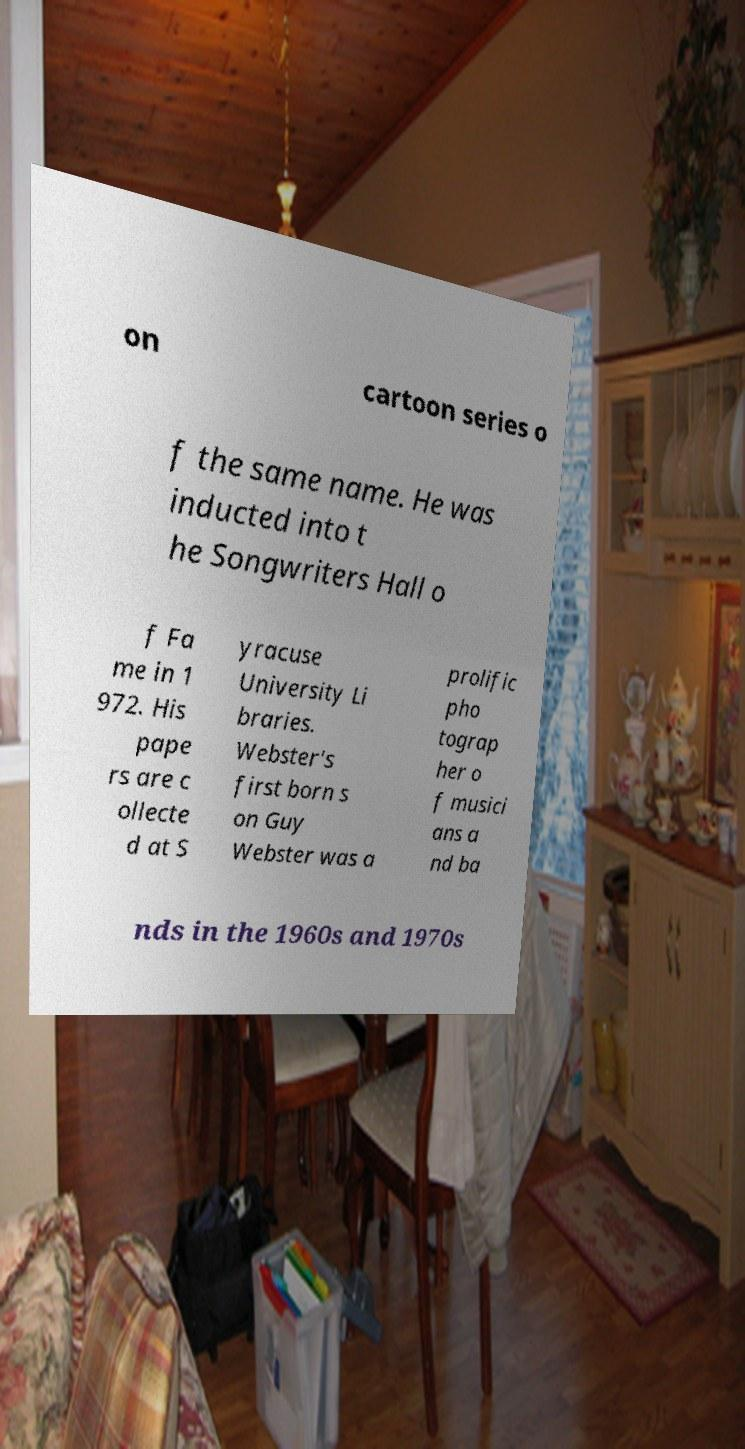Could you assist in decoding the text presented in this image and type it out clearly? on cartoon series o f the same name. He was inducted into t he Songwriters Hall o f Fa me in 1 972. His pape rs are c ollecte d at S yracuse University Li braries. Webster's first born s on Guy Webster was a prolific pho tograp her o f musici ans a nd ba nds in the 1960s and 1970s 